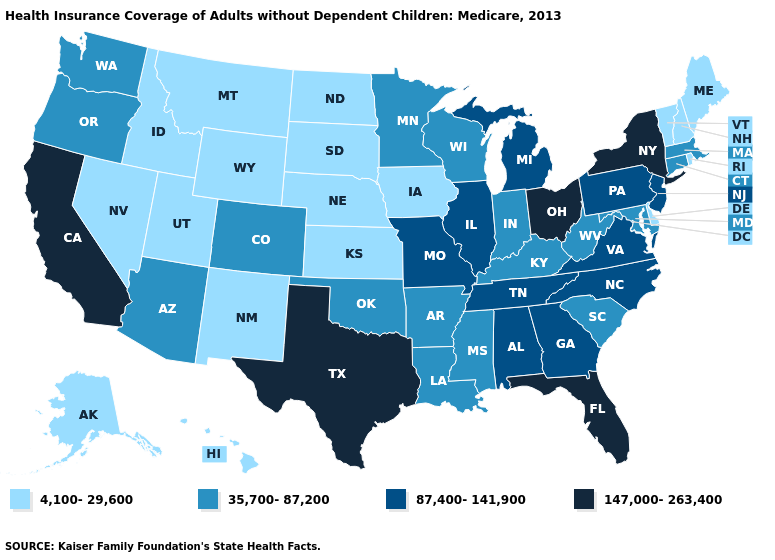What is the value of Alabama?
Quick response, please. 87,400-141,900. What is the highest value in states that border Idaho?
Give a very brief answer. 35,700-87,200. What is the value of Mississippi?
Answer briefly. 35,700-87,200. What is the value of Mississippi?
Short answer required. 35,700-87,200. Name the states that have a value in the range 147,000-263,400?
Short answer required. California, Florida, New York, Ohio, Texas. Does California have the same value as Texas?
Give a very brief answer. Yes. Name the states that have a value in the range 87,400-141,900?
Keep it brief. Alabama, Georgia, Illinois, Michigan, Missouri, New Jersey, North Carolina, Pennsylvania, Tennessee, Virginia. What is the value of Alabama?
Answer briefly. 87,400-141,900. What is the lowest value in the MidWest?
Write a very short answer. 4,100-29,600. Does the first symbol in the legend represent the smallest category?
Concise answer only. Yes. What is the value of Vermont?
Keep it brief. 4,100-29,600. Name the states that have a value in the range 35,700-87,200?
Concise answer only. Arizona, Arkansas, Colorado, Connecticut, Indiana, Kentucky, Louisiana, Maryland, Massachusetts, Minnesota, Mississippi, Oklahoma, Oregon, South Carolina, Washington, West Virginia, Wisconsin. Name the states that have a value in the range 4,100-29,600?
Short answer required. Alaska, Delaware, Hawaii, Idaho, Iowa, Kansas, Maine, Montana, Nebraska, Nevada, New Hampshire, New Mexico, North Dakota, Rhode Island, South Dakota, Utah, Vermont, Wyoming. What is the lowest value in the Northeast?
Give a very brief answer. 4,100-29,600. 